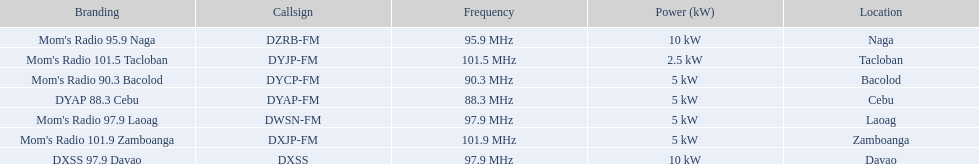What are the frequencies for radios of dyap-fm? 97.9 MHz, 95.9 MHz, 90.3 MHz, 88.3 MHz, 101.5 MHz, 101.9 MHz, 97.9 MHz. What is the lowest frequency? 88.3 MHz. Which radio has this frequency? DYAP 88.3 Cebu. 